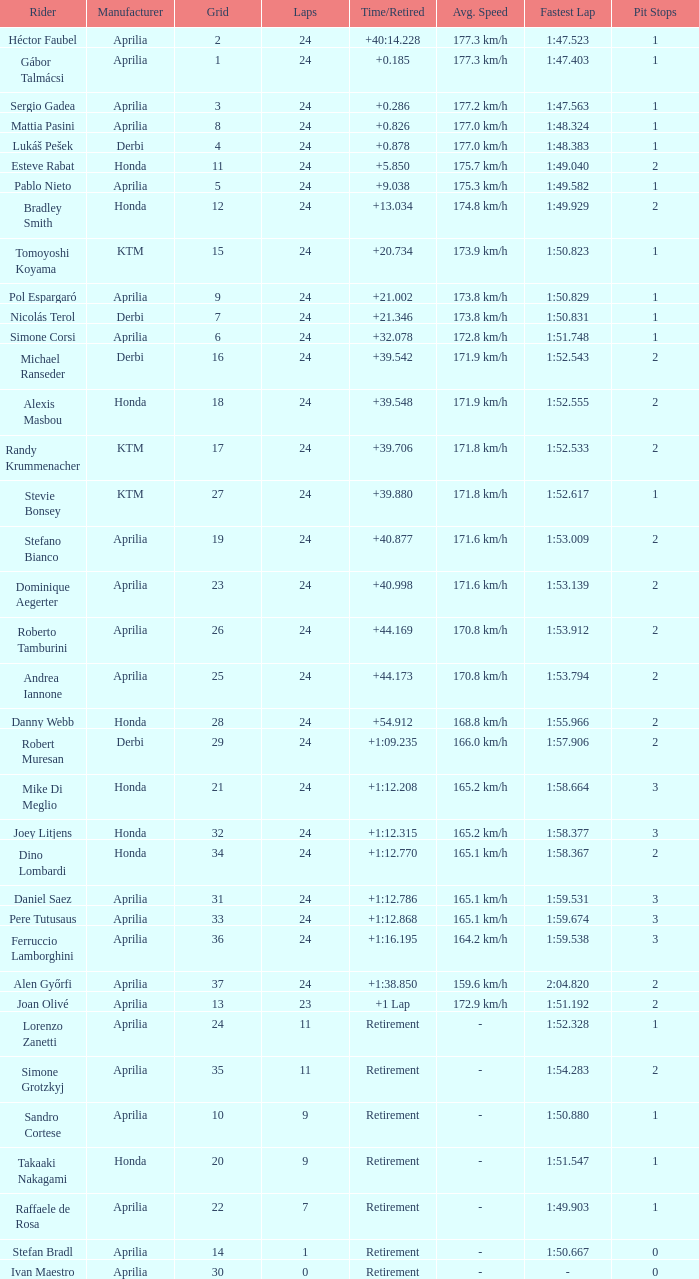How many grids have more than 24 laps with a time/retired of +1:12.208? None. 